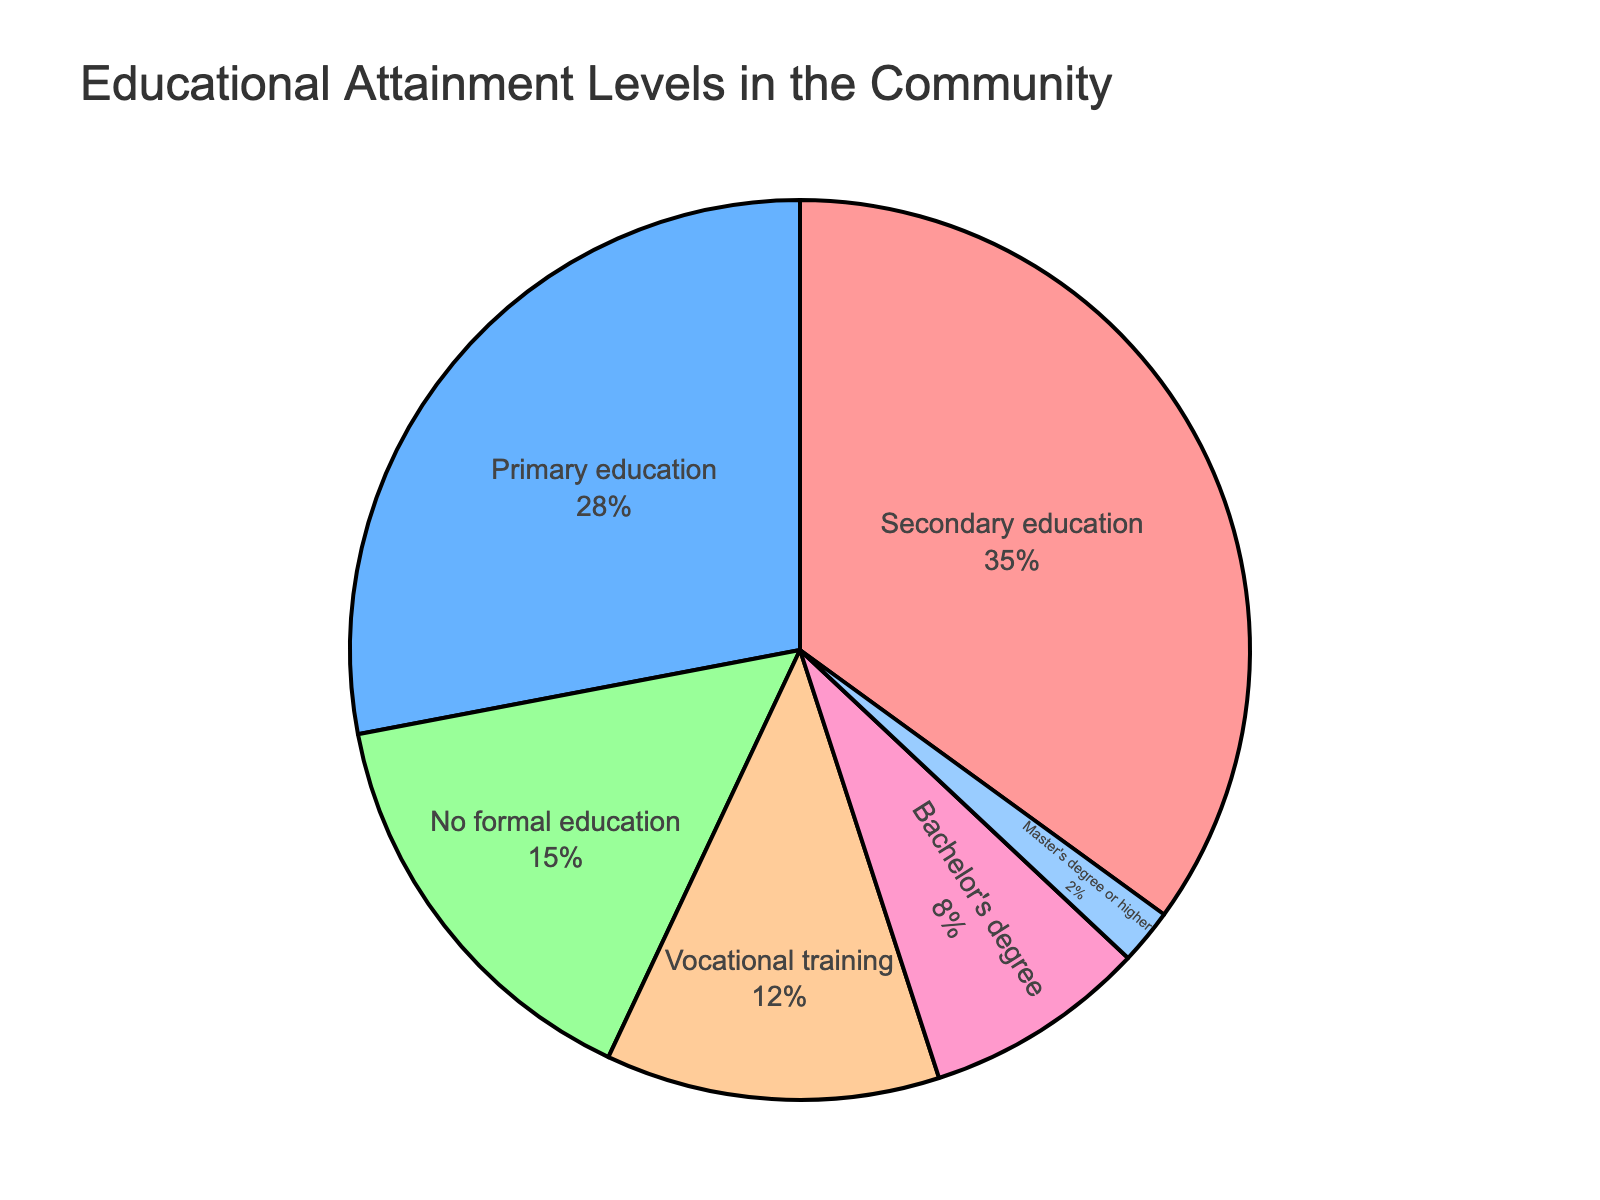What's the percentage of community members with at least a Bachelor's degree? To find the percentage of community members with at least a Bachelor's degree, we add the percentages of those with a Bachelor's degree (8%) and those with a Master's degree or higher (2%). So, 8% + 2% = 10%.
Answer: 10% Which two education levels have the highest and second-highest percentages? The two education levels with the highest percentages are Secondary education at 35% and Primary education at 28%.
Answer: Secondary education and Primary education Which segment represents the smallest share of educational attainment? The smallest segment in the pie chart represents the education level with the lowest percentage, which is Master's degree or higher at 2%.
Answer: Master's degree or higher How much larger is the Primary education segment compared to the Vocational training segment? To find how much larger the Primary education segment is compared to the Vocational training segment, we subtract the percentage of Vocational training (12%) from the Primary education (28%). So, 28% - 12% = 16%.
Answer: 16% What is the combined percentage of community members with Primary and Secondary education? To find the combined percentage, add the percentages of community members with Primary education (28%) and Secondary education (35%). So, 28% + 35% = 63%.
Answer: 63% Is the percentage of community members with no formal education greater than the percentage with Vocational training? The percentage of community members with no formal education is 15%, which is greater than the percentage with Vocational training at 12%.
Answer: Yes Which educational attainment level is represented by the green segment in the pie chart? The green segment in the pie chart corresponds to Secondary education based on the predefined colors in the figure.
Answer: Secondary education What proportion of the community members have attained at least Secondary education? To find the proportion with at least Secondary education, add the percentages of those with Secondary education (35%), Vocational training (12%), Bachelor's degree (8%), and Master's degree or higher (2%). So, 35% + 12% + 8% + 2% = 57%.
Answer: 57% By what percentage does Secondary education exceed No formal education? To find the percentage by which Secondary education exceeds No formal education, subtract the percentage of No formal education (15%) from Secondary education (35%). So, 35% - 15% = 20%.
Answer: 20% Rank the education levels from highest to lowest percentage. The rankings from highest to lowest percentage are: Secondary education (35%), Primary education (28%), No formal education (15%), Vocational training (12%), Bachelor's degree (8%), Master's degree or higher (2%).
Answer: Secondary education, Primary education, No formal education, Vocational training, Bachelor's degree, Master's degree or higher 